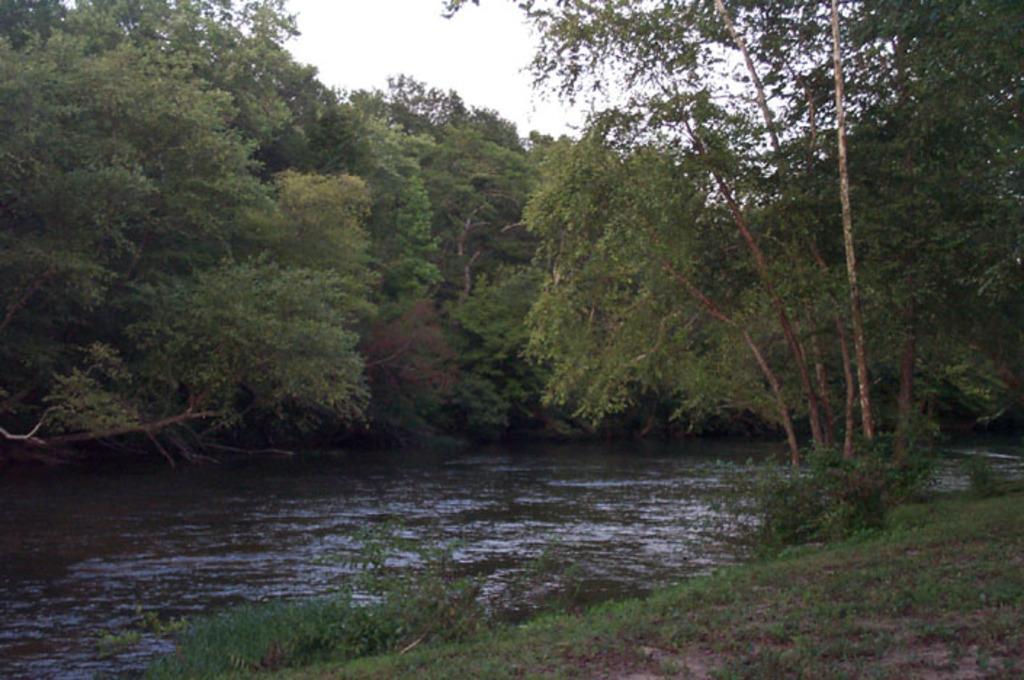Please provide a concise description of this image. At the bottom of the picture, we see the grass and the shrubs. In the middle, we see water and this water might be in the lake. There are trees in the background. At the top, we see the sky. 